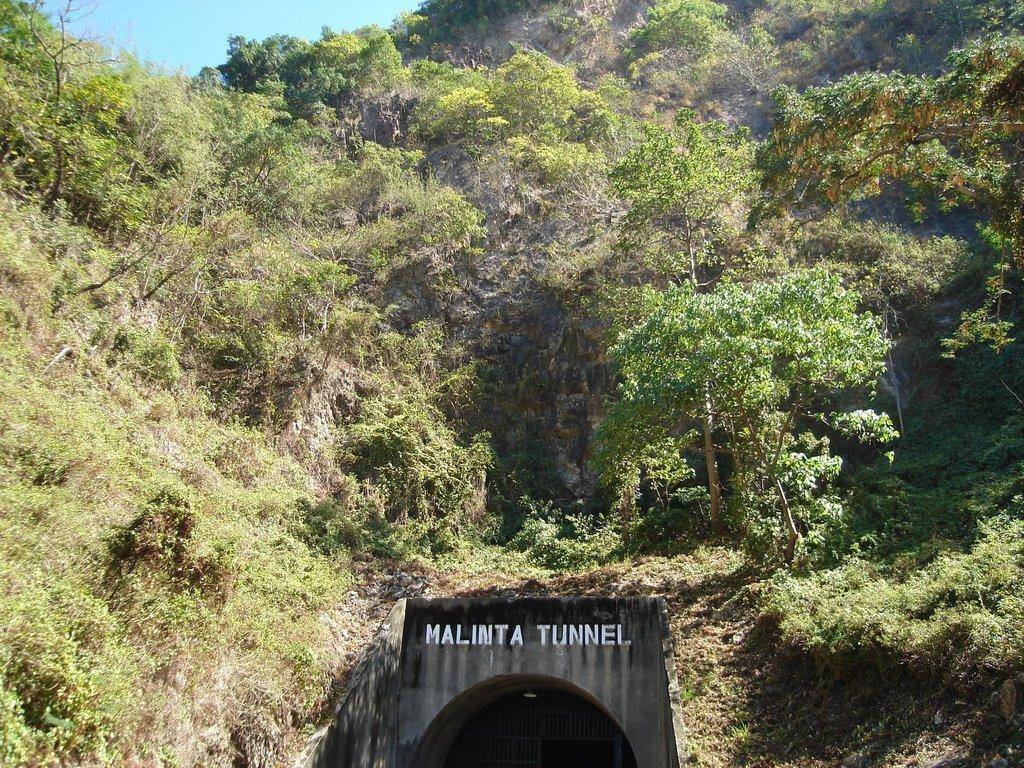What is located in the middle of the image? There is a tunnel in the middle of the image. What can be seen above the tunnel in the image? There are trees visible above the tunnel in the image. What type of curve can be seen in the neck of the clam in the image? There is no clam or neck present in the image; it features a tunnel with trees visible above it. 